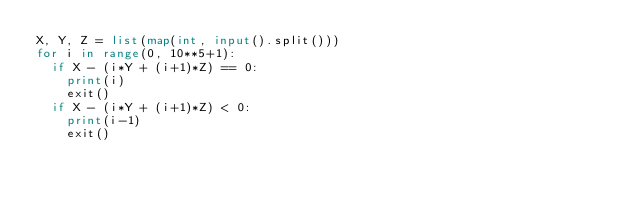<code> <loc_0><loc_0><loc_500><loc_500><_Python_>X, Y, Z = list(map(int, input().split()))
for i in range(0, 10**5+1):
  if X - (i*Y + (i+1)*Z) == 0:
    print(i)
    exit()
  if X - (i*Y + (i+1)*Z) < 0:
    print(i-1)
    exit()</code> 